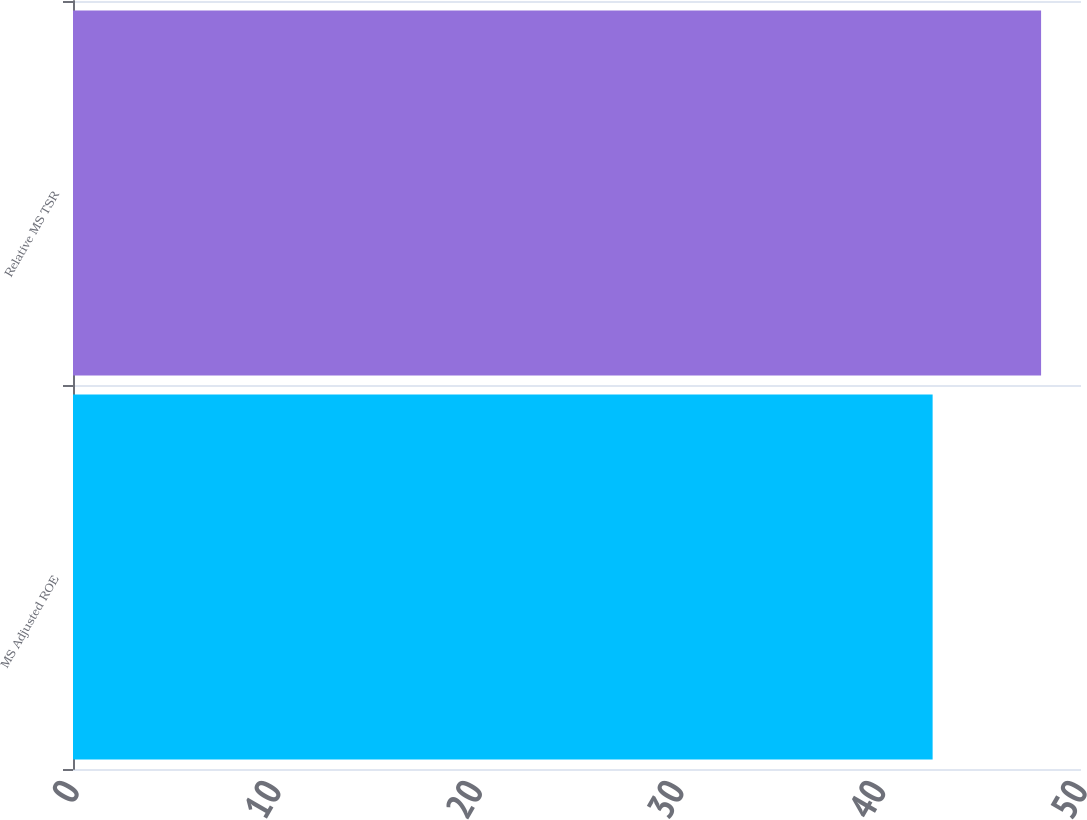Convert chart to OTSL. <chart><loc_0><loc_0><loc_500><loc_500><bar_chart><fcel>MS Adjusted ROE<fcel>Relative MS TSR<nl><fcel>42.64<fcel>48.02<nl></chart> 